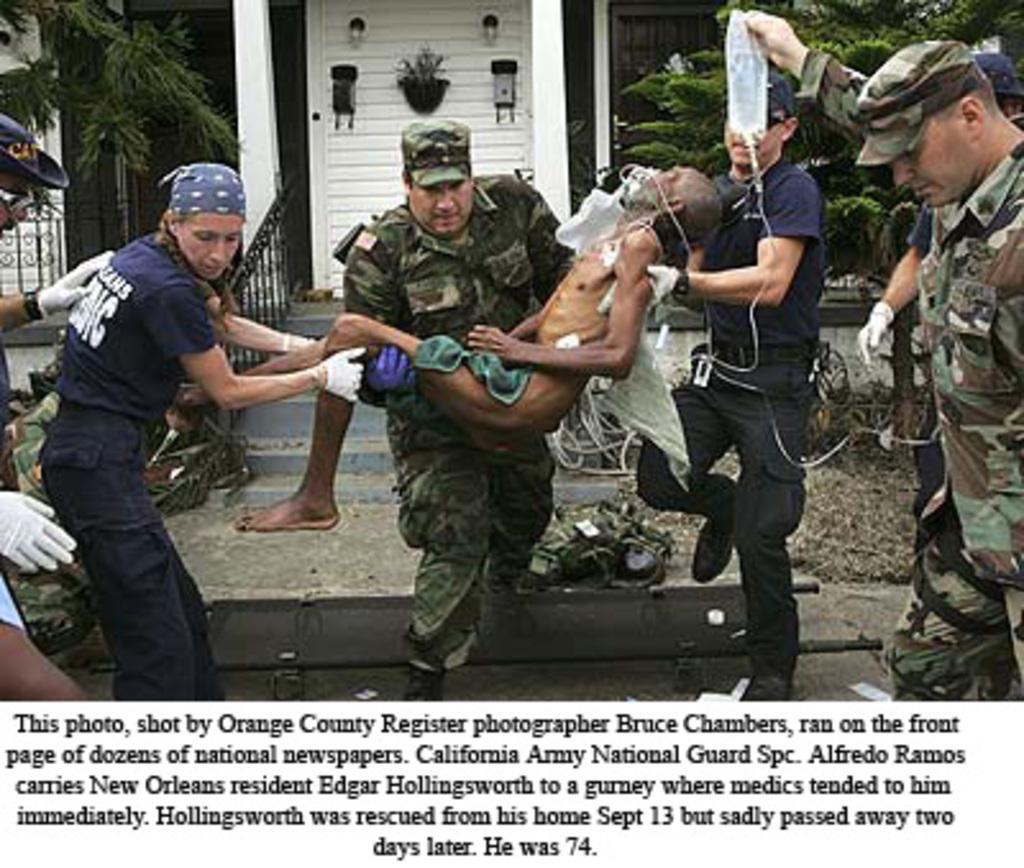In one or two sentences, can you explain what this image depicts? In this image we can see a person wearing cap is holding another person. There are many people. They are wearing caps and gloves. One person is holding a packet. In the back there is a building with railing, steps. Also there are trees. At the bottom of the image something is written. 